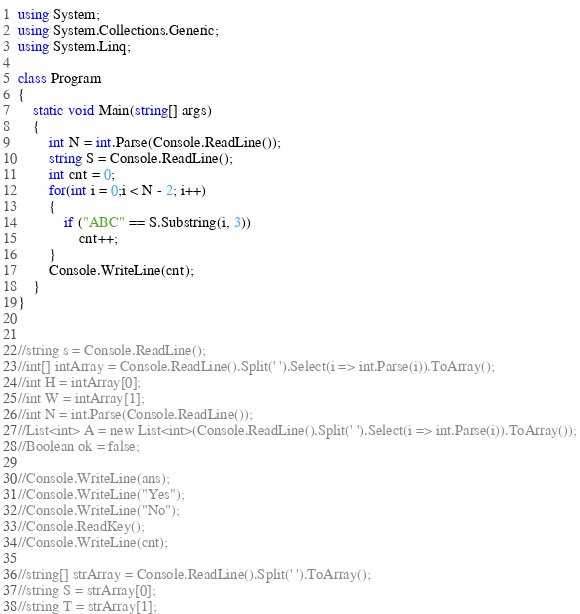Convert code to text. <code><loc_0><loc_0><loc_500><loc_500><_C#_>using System;
using System.Collections.Generic;
using System.Linq;

class Program
{
	static void Main(string[] args)
	{
		int N = int.Parse(Console.ReadLine());
		string S = Console.ReadLine();
		int cnt = 0;
		for(int i = 0;i < N - 2; i++)
        {
			if ("ABC" == S.Substring(i, 3))
				cnt++;
        }
		Console.WriteLine(cnt);
	}
}


//string s = Console.ReadLine();
//int[] intArray = Console.ReadLine().Split(' ').Select(i => int.Parse(i)).ToArray();
//int H = intArray[0];
//int W = intArray[1];
//int N = int.Parse(Console.ReadLine());
//List<int> A = new List<int>(Console.ReadLine().Split(' ').Select(i => int.Parse(i)).ToArray());
//Boolean ok = false;

//Console.WriteLine(ans);
//Console.WriteLine("Yes");
//Console.WriteLine("No");
//Console.ReadKey();
//Console.WriteLine(cnt);

//string[] strArray = Console.ReadLine().Split(' ').ToArray();
//string S = strArray[0];
//string T = strArray[1];
</code> 